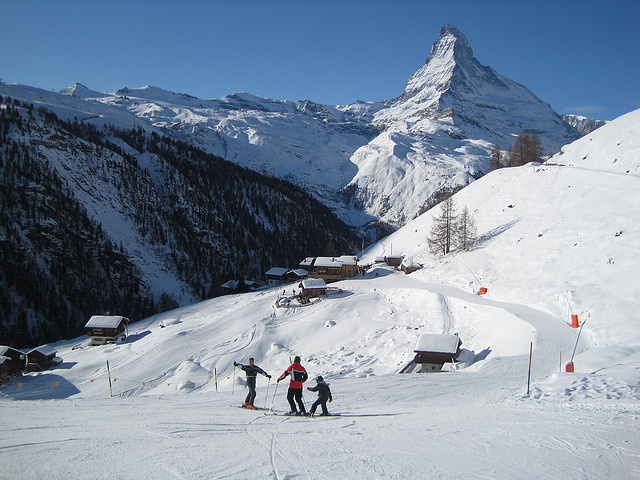Describe the objects in this image and their specific colors. I can see people in gray, black, lightgray, maroon, and darkgray tones, people in gray, black, navy, and darkgray tones, people in gray, black, lightgray, and navy tones, skis in gray, darkgray, black, and lightgray tones, and skis in gray, black, navy, darkgray, and blue tones in this image. 